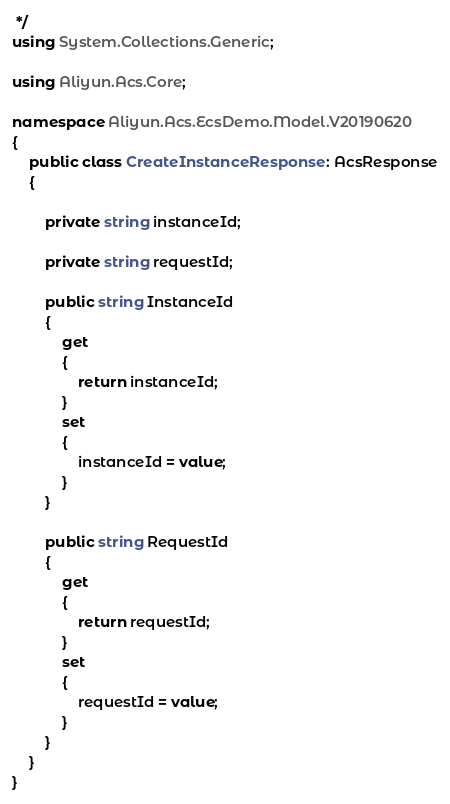<code> <loc_0><loc_0><loc_500><loc_500><_C#_> */
using System.Collections.Generic;

using Aliyun.Acs.Core;

namespace Aliyun.Acs.EcsDemo.Model.V20190620
{
	public class CreateInstanceResponse : AcsResponse
	{

		private string instanceId;

		private string requestId;

		public string InstanceId
		{
			get
			{
				return instanceId;
			}
			set	
			{
				instanceId = value;
			}
		}

		public string RequestId
		{
			get
			{
				return requestId;
			}
			set	
			{
				requestId = value;
			}
		}
	}
}
</code> 